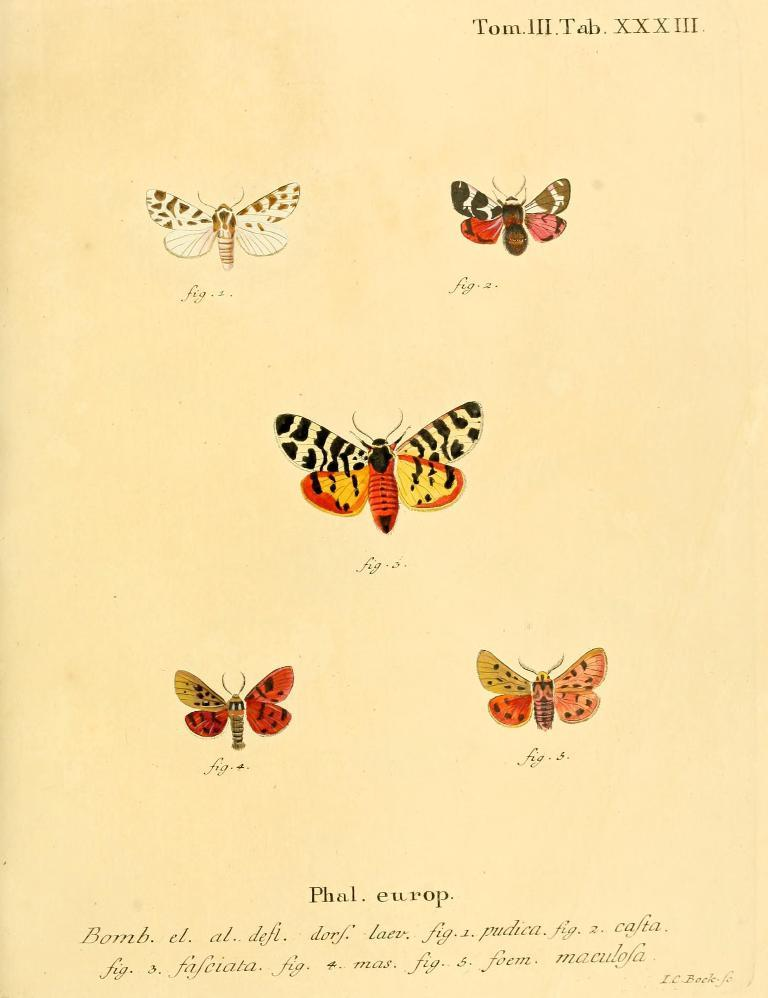What is the main subject of the paper in the image? The paper contains pictures of butterflies. Are there any words or letters on the paper? Yes, there is text on the paper. What type of cave can be seen in the background of the image? There is no cave present in the image; it features a paper with butterfly pictures and text. What reward is being offered for finding the missing expansion? There is no mention of a reward or missing expansion in the image. 